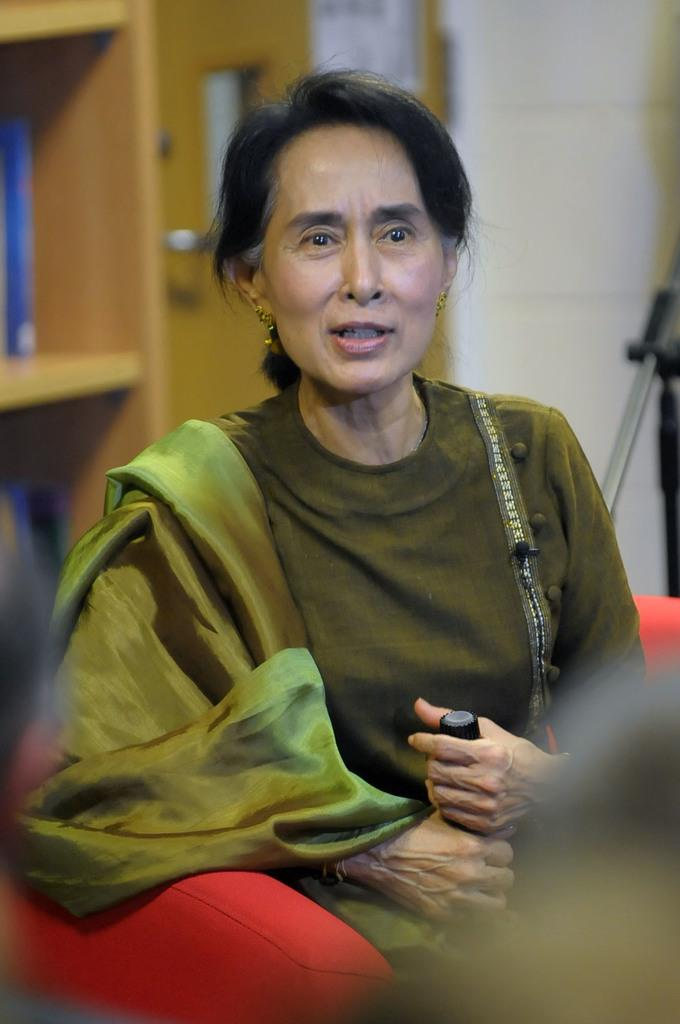What is the main subject of the image? There is a woman sitting in the middle of the image. What is the woman holding in her hand? The woman is holding something in her hand, but the specific object cannot be determined from the facts provided. What is located behind the woman? There is a wall behind the woman. Can you describe any architectural features in the image? Yes, there is a door visible in the image, and there is also a cupboard. What type of fold can be seen in the woman's clothing in the image? There is no information about the woman's clothing or any folds in the image, so this cannot be answered definitively. 